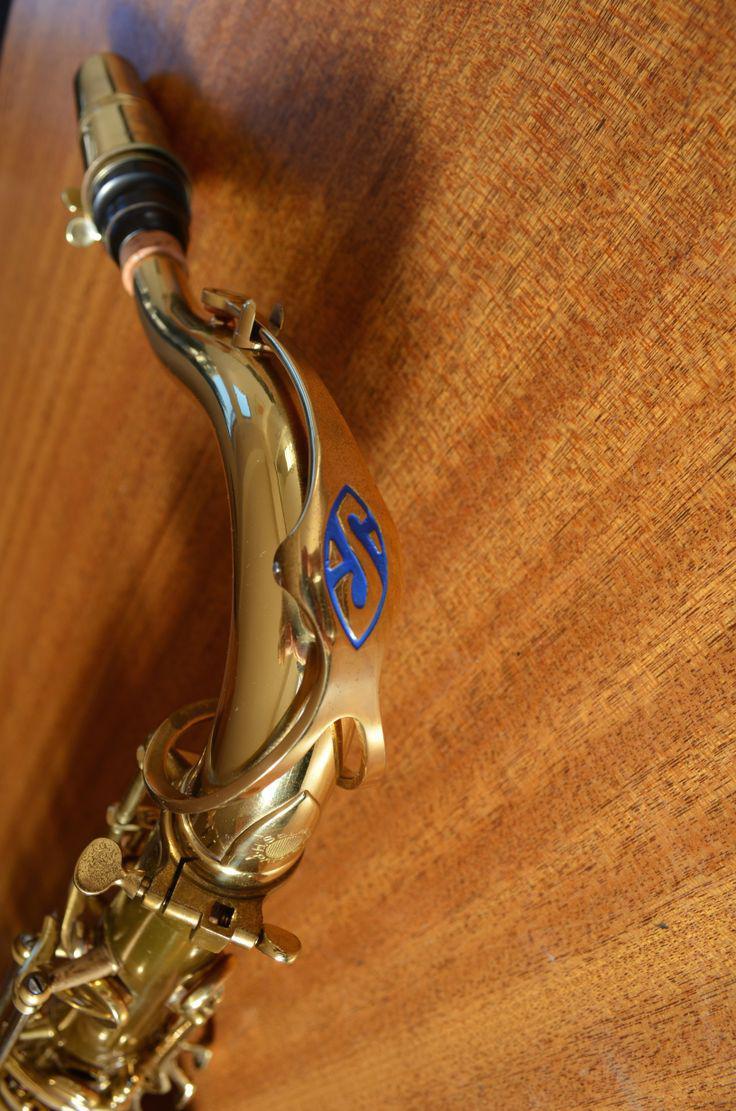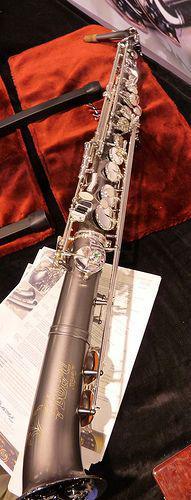The first image is the image on the left, the second image is the image on the right. Examine the images to the left and right. Is the description "Each image shows a single upright instrument on a plain background." accurate? Answer yes or no. No. The first image is the image on the left, the second image is the image on the right. Given the left and right images, does the statement "The entire length of one saxophone is shown in each image." hold true? Answer yes or no. No. 